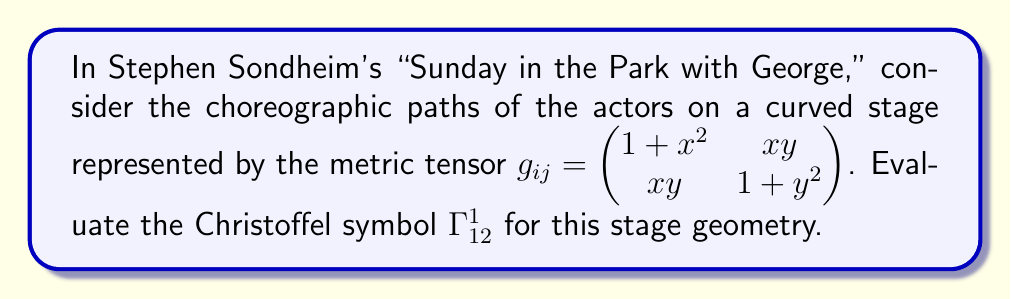Solve this math problem. To evaluate the Christoffel symbol $\Gamma^1_{12}$, we'll follow these steps:

1) The formula for the Christoffel symbol is:

   $$\Gamma^k_{ij} = \frac{1}{2}g^{kl}\left(\frac{\partial g_{jl}}{\partial x^i} + \frac{\partial g_{il}}{\partial x^j} - \frac{\partial g_{ij}}{\partial x^l}\right)$$

2) For $\Gamma^1_{12}$, we need to calculate:

   $$\Gamma^1_{12} = \frac{1}{2}g^{1l}\left(\frac{\partial g_{2l}}{\partial x^1} + \frac{\partial g_{1l}}{\partial x^2} - \frac{\partial g_{12}}{\partial x^l}\right)$$

3) First, we need to find the inverse metric tensor $g^{ij}$:

   $$g^{ij} = \frac{1}{(1+x^2)(1+y^2)-x^2y^2}\begin{pmatrix} 1+y^2 & -xy \\ -xy & 1+x^2 \end{pmatrix}$$

4) Now, we calculate the partial derivatives:

   $\frac{\partial g_{21}}{\partial x^1} = \frac{\partial (xy)}{\partial x} = y$
   
   $\frac{\partial g_{11}}{\partial x^2} = \frac{\partial (1+x^2)}{\partial y} = 0$
   
   $\frac{\partial g_{12}}{\partial x^1} = \frac{\partial (xy)}{\partial x} = y$
   
   $\frac{\partial g_{12}}{\partial x^2} = \frac{\partial (xy)}{\partial y} = x$

5) Substituting into the formula:

   $$\Gamma^1_{12} = \frac{1}{2}[g^{11}(y + 0 - y) + g^{12}(x - x)] = 0$$

6) Therefore, $\Gamma^1_{12} = 0$ for this stage geometry.
Answer: $\Gamma^1_{12} = 0$ 